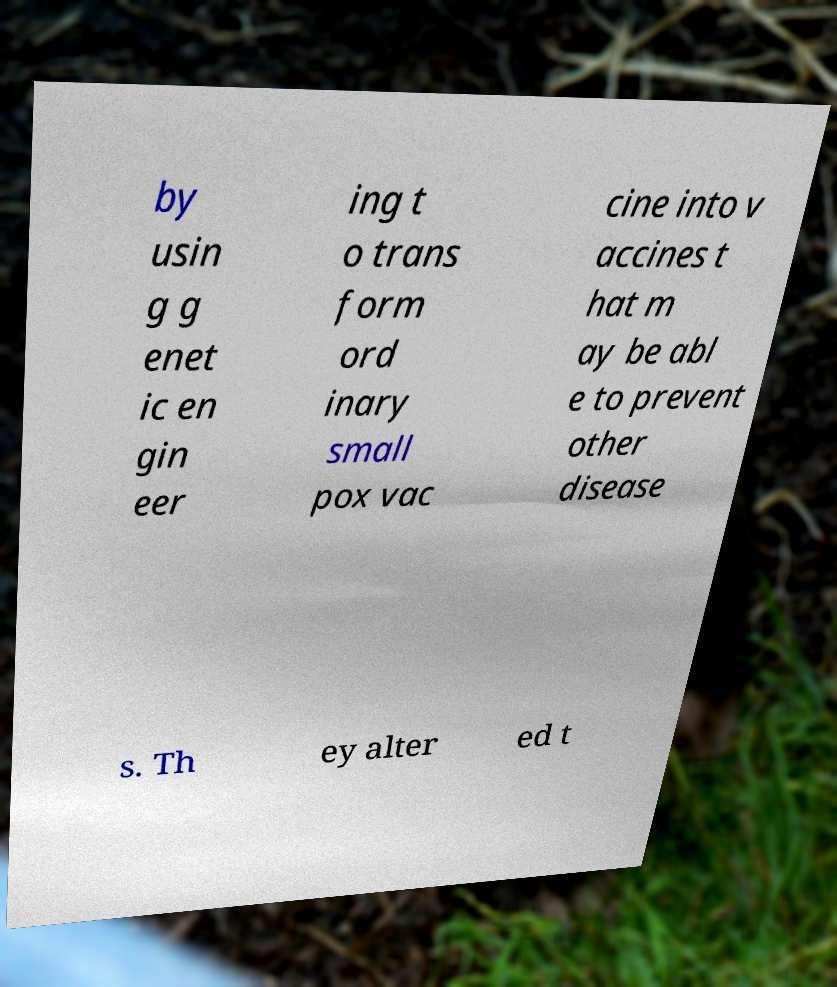What messages or text are displayed in this image? I need them in a readable, typed format. by usin g g enet ic en gin eer ing t o trans form ord inary small pox vac cine into v accines t hat m ay be abl e to prevent other disease s. Th ey alter ed t 